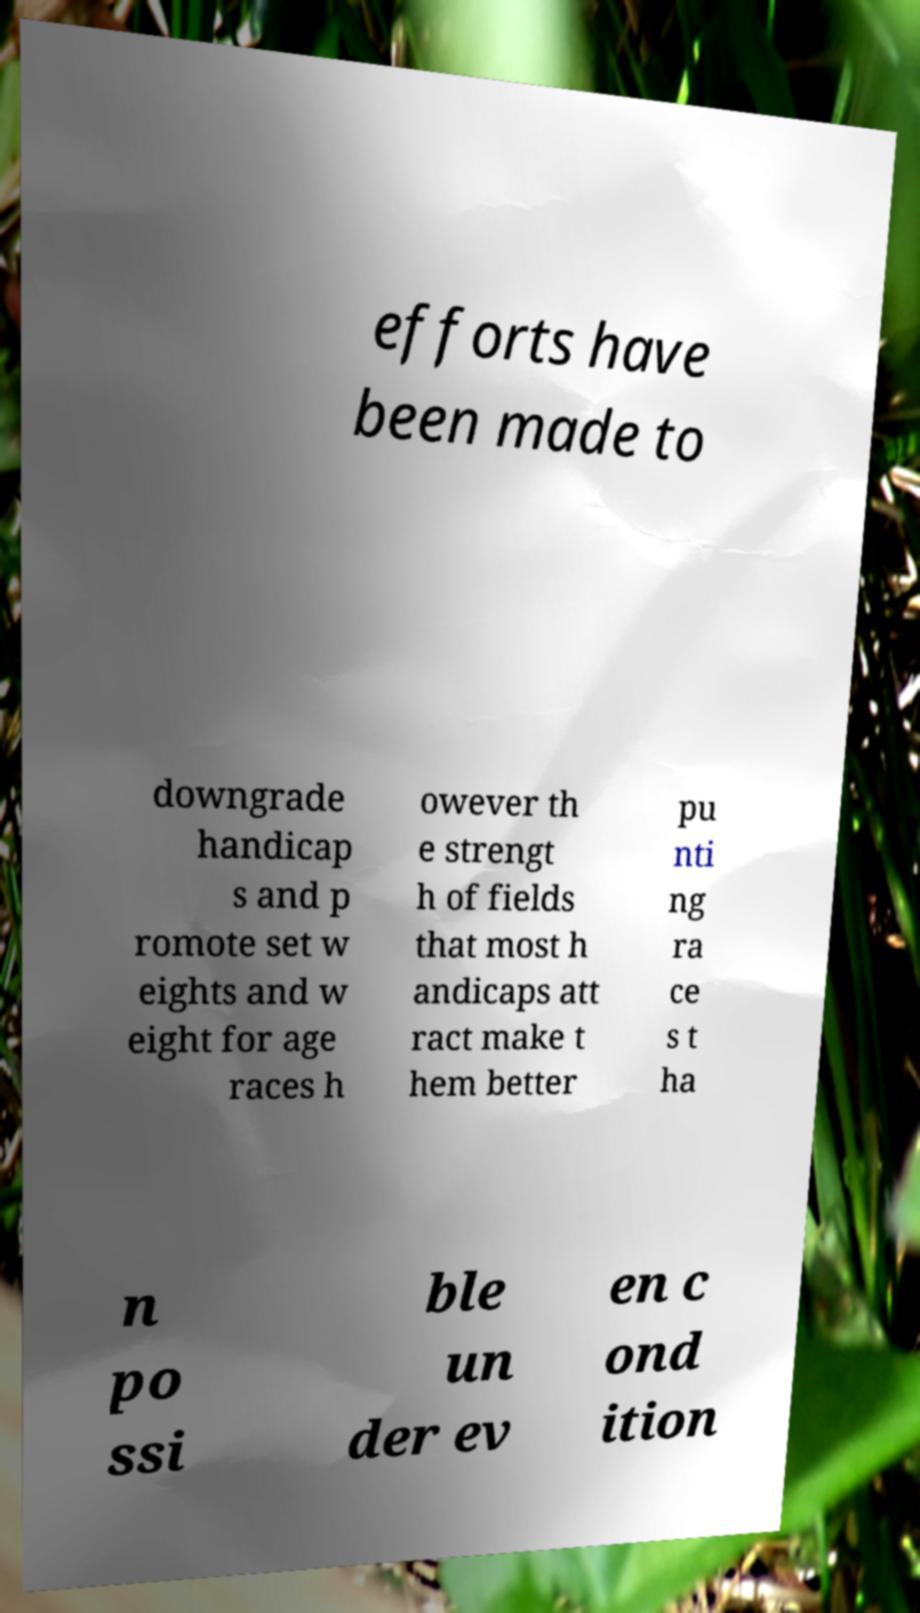Could you assist in decoding the text presented in this image and type it out clearly? efforts have been made to downgrade handicap s and p romote set w eights and w eight for age races h owever th e strengt h of fields that most h andicaps att ract make t hem better pu nti ng ra ce s t ha n po ssi ble un der ev en c ond ition 